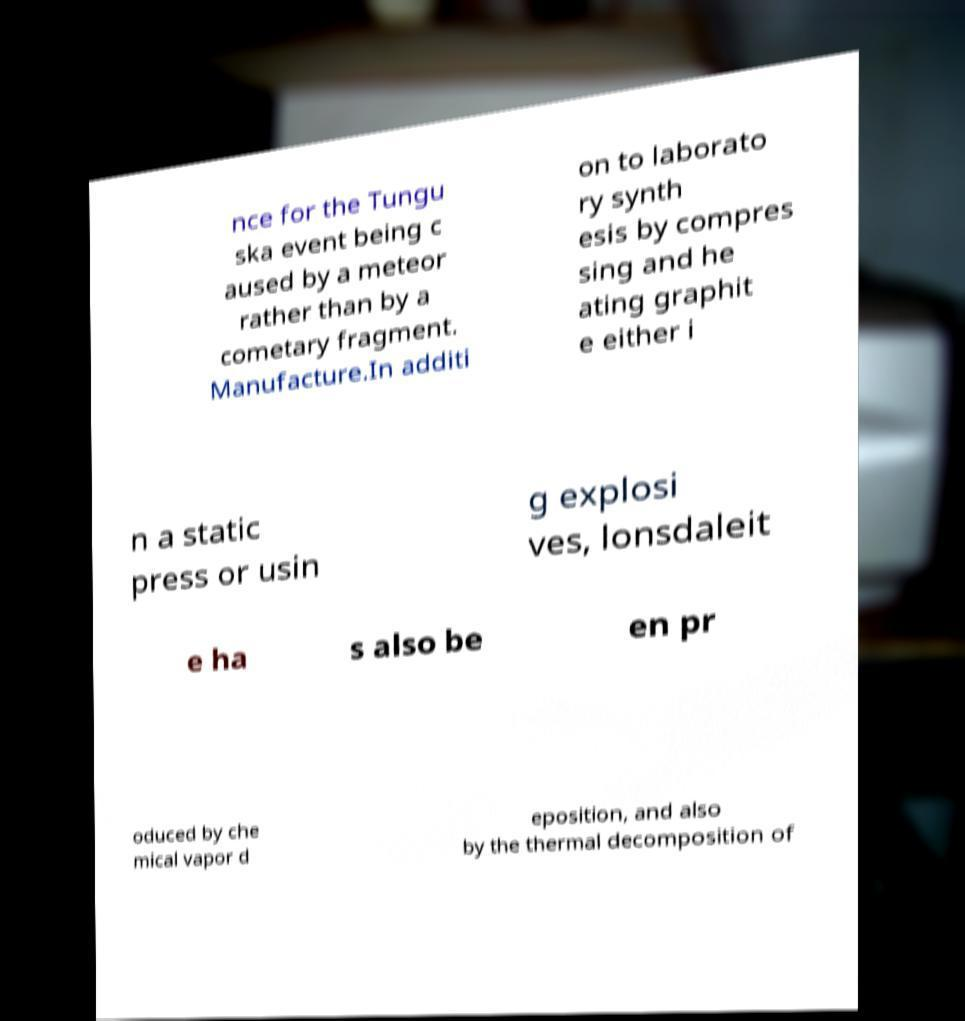Can you read and provide the text displayed in the image?This photo seems to have some interesting text. Can you extract and type it out for me? nce for the Tungu ska event being c aused by a meteor rather than by a cometary fragment. Manufacture.In additi on to laborato ry synth esis by compres sing and he ating graphit e either i n a static press or usin g explosi ves, lonsdaleit e ha s also be en pr oduced by che mical vapor d eposition, and also by the thermal decomposition of 